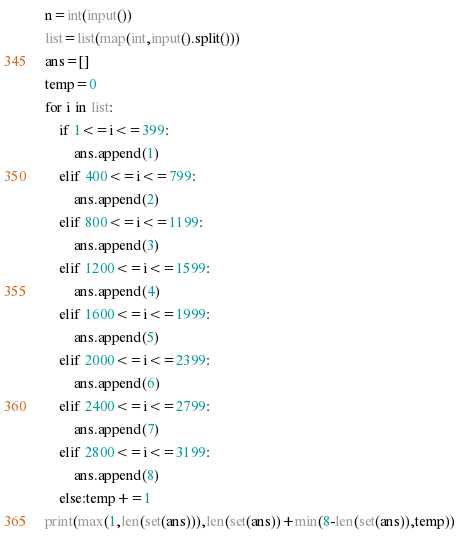<code> <loc_0><loc_0><loc_500><loc_500><_Python_>n=int(input())
list=list(map(int,input().split()))
ans=[]
temp=0
for i in list:
    if 1<=i<=399:
        ans.append(1)
    elif 400<=i<=799:
        ans.append(2)
    elif 800<=i<=1199:
        ans.append(3)
    elif 1200<=i<=1599:
        ans.append(4)
    elif 1600<=i<=1999:
        ans.append(5)
    elif 2000<=i<=2399:
        ans.append(6)
    elif 2400<=i<=2799:
        ans.append(7)
    elif 2800<=i<=3199:
        ans.append(8)
    else:temp+=1
print(max(1,len(set(ans))),len(set(ans))+min(8-len(set(ans)),temp))</code> 